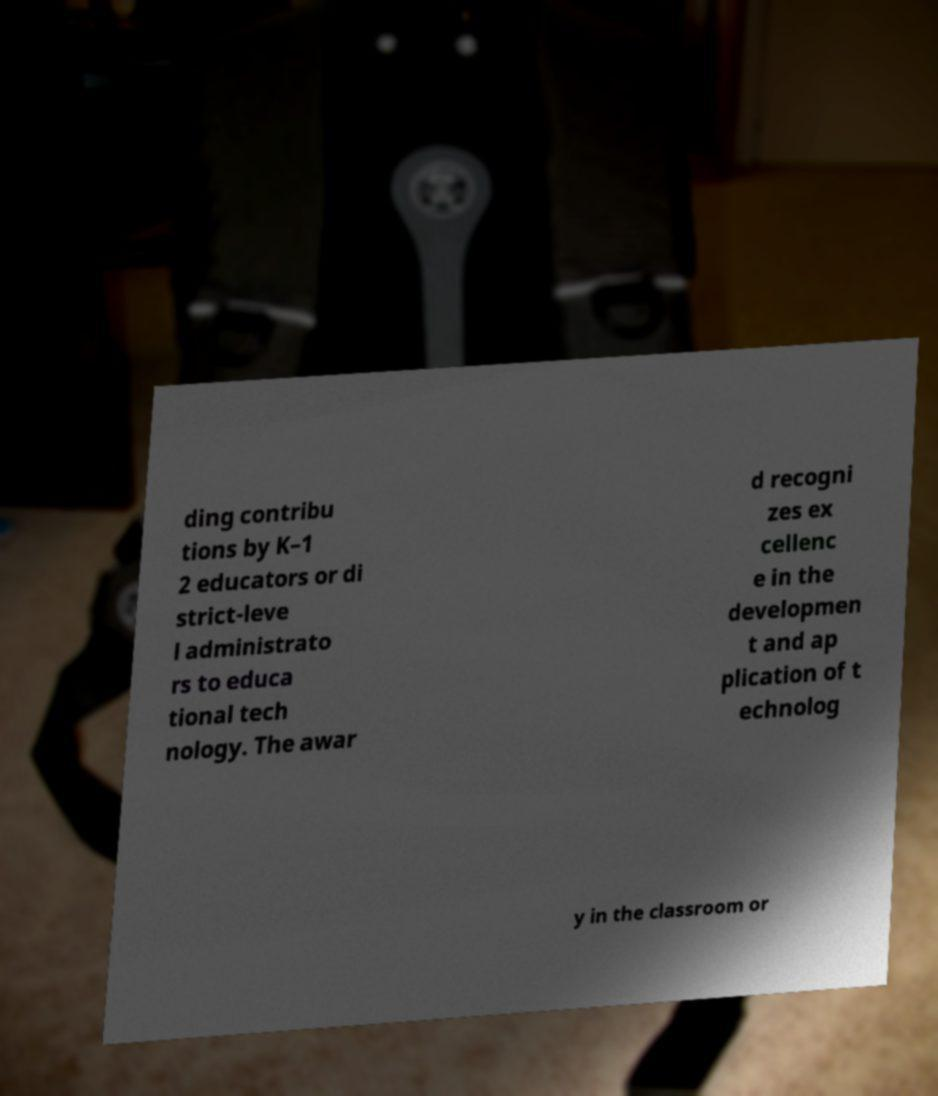For documentation purposes, I need the text within this image transcribed. Could you provide that? ding contribu tions by K–1 2 educators or di strict-leve l administrato rs to educa tional tech nology. The awar d recogni zes ex cellenc e in the developmen t and ap plication of t echnolog y in the classroom or 